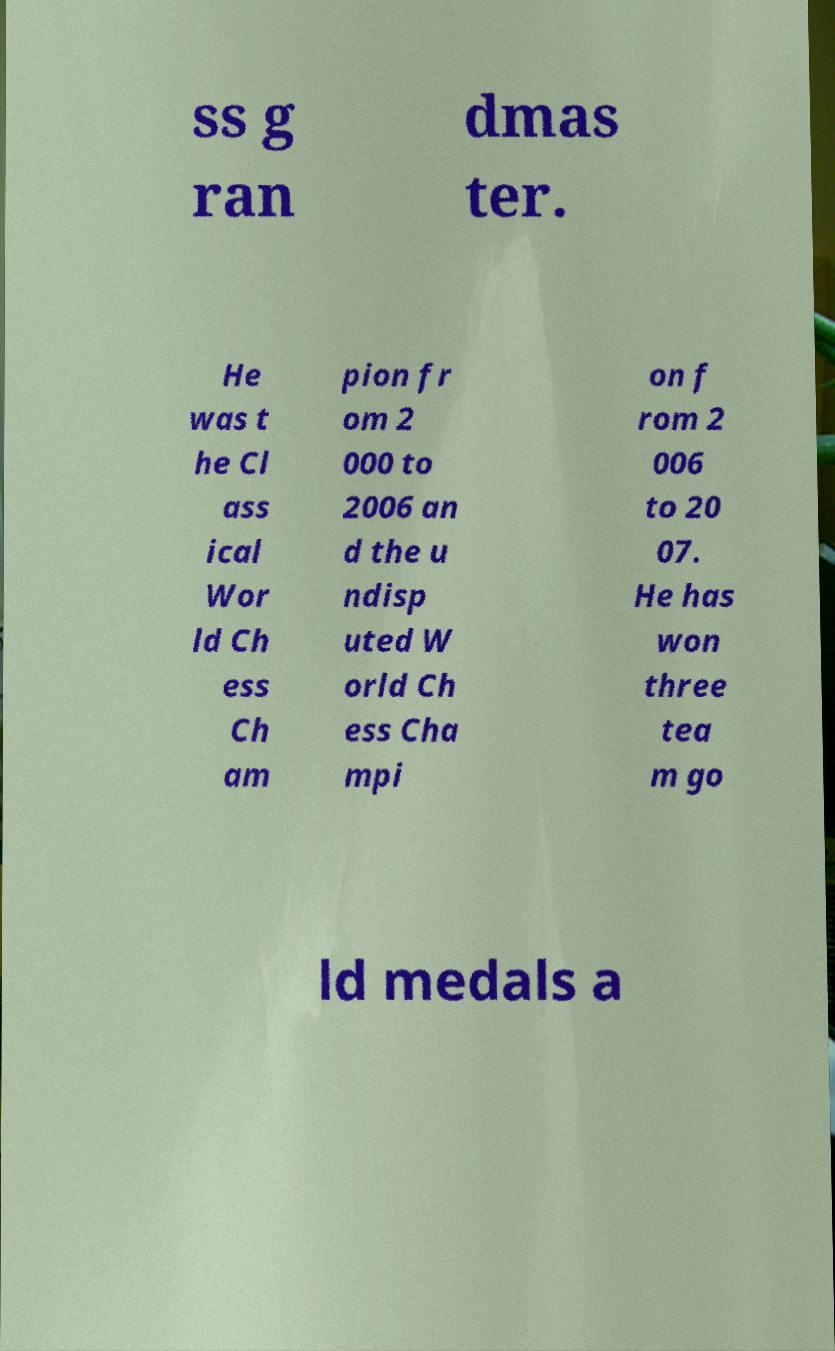Please identify and transcribe the text found in this image. ss g ran dmas ter. He was t he Cl ass ical Wor ld Ch ess Ch am pion fr om 2 000 to 2006 an d the u ndisp uted W orld Ch ess Cha mpi on f rom 2 006 to 20 07. He has won three tea m go ld medals a 